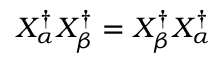Convert formula to latex. <formula><loc_0><loc_0><loc_500><loc_500>X _ { \alpha } ^ { \dag } X _ { \beta } ^ { \dag } = X _ { \beta } ^ { \dag } X _ { \alpha } ^ { \dag }</formula> 